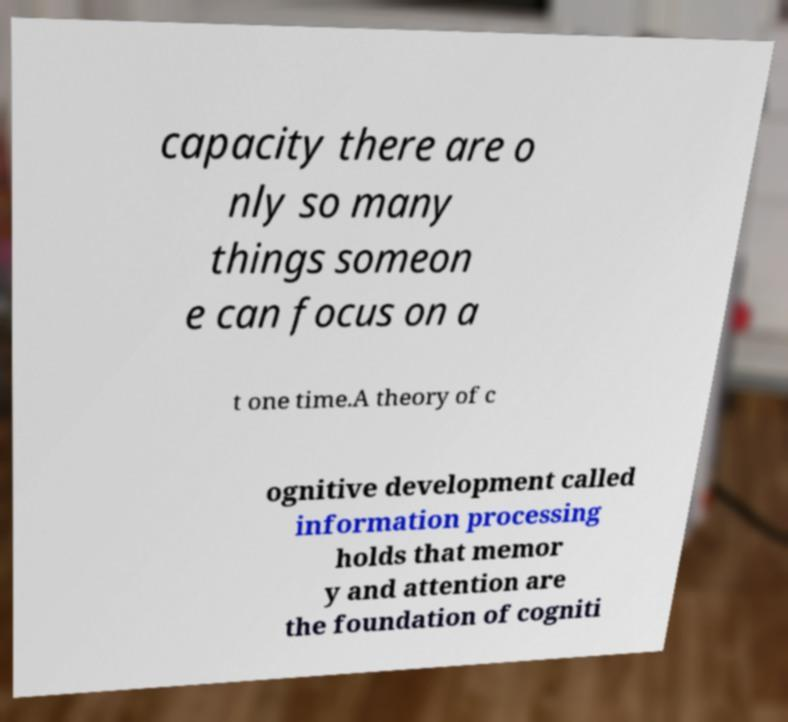What messages or text are displayed in this image? I need them in a readable, typed format. capacity there are o nly so many things someon e can focus on a t one time.A theory of c ognitive development called information processing holds that memor y and attention are the foundation of cogniti 